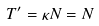Convert formula to latex. <formula><loc_0><loc_0><loc_500><loc_500>T ^ { \prime } = \kappa N = N</formula> 